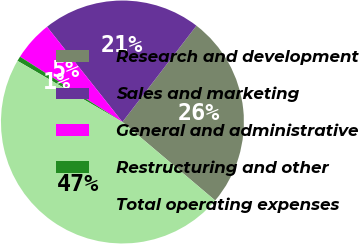Convert chart to OTSL. <chart><loc_0><loc_0><loc_500><loc_500><pie_chart><fcel>Research and development<fcel>Sales and marketing<fcel>General and administrative<fcel>Restructuring and other<fcel>Total operating expenses<nl><fcel>25.75%<fcel>21.09%<fcel>5.3%<fcel>0.64%<fcel>47.22%<nl></chart> 